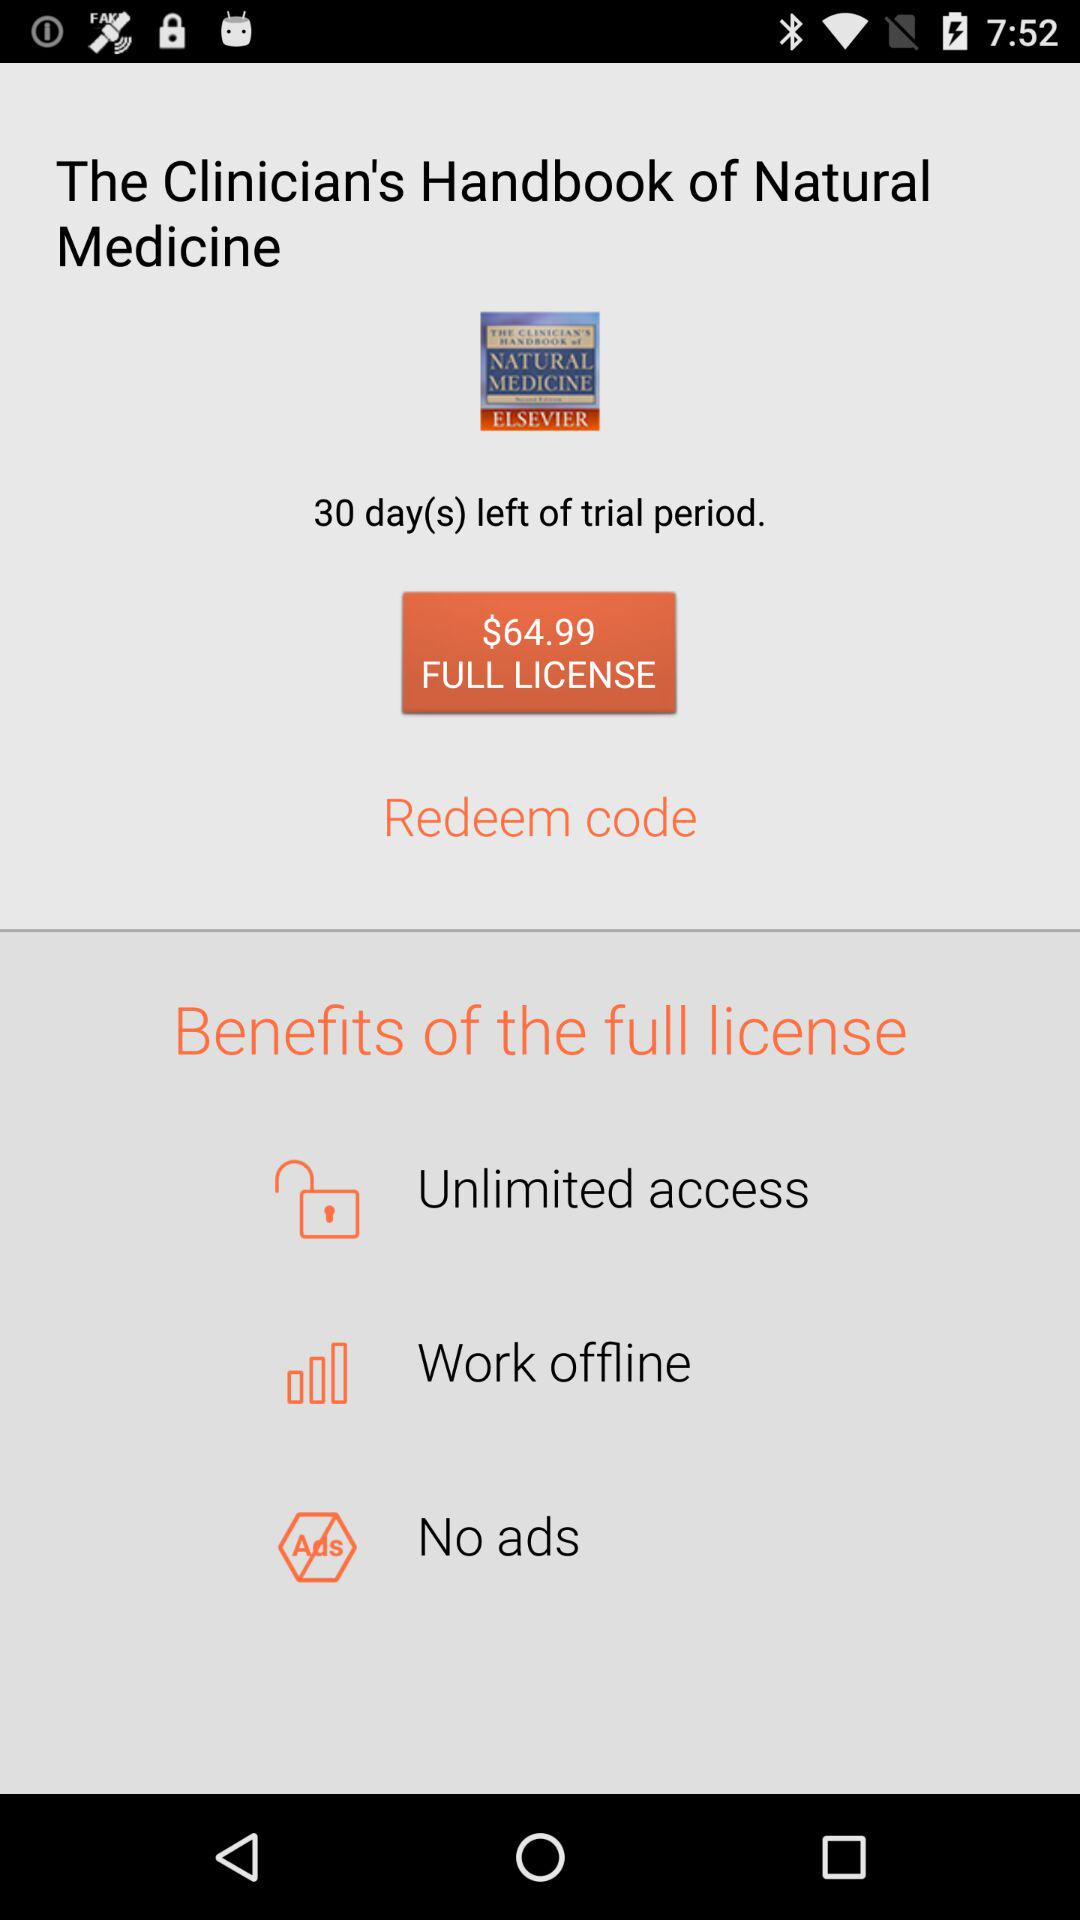How much is the full license?
Answer the question using a single word or phrase. $64.99 